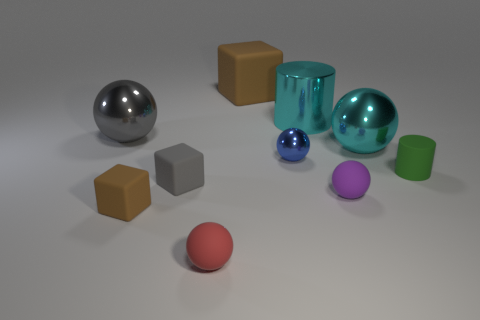What is the big cube made of?
Make the answer very short. Rubber. What material is the cylinder behind the large sphere to the left of the brown matte cube left of the big brown rubber cube made of?
Provide a succinct answer. Metal. Is there any other thing that is the same material as the big cylinder?
Keep it short and to the point. Yes. Does the purple sphere have the same size as the block right of the red object?
Make the answer very short. No. How many things are either tiny matte spheres that are behind the small brown thing or rubber cubes that are behind the tiny matte cylinder?
Offer a terse response. 2. The big sphere that is right of the big cube is what color?
Make the answer very short. Cyan. Are there any large cubes that are to the right of the matte sphere right of the big brown object?
Keep it short and to the point. No. Are there fewer matte cylinders than small cyan metallic cubes?
Give a very brief answer. No. What is the material of the big sphere that is on the left side of the brown matte object behind the metallic cylinder?
Offer a very short reply. Metal. Is the red sphere the same size as the matte cylinder?
Ensure brevity in your answer.  Yes. 